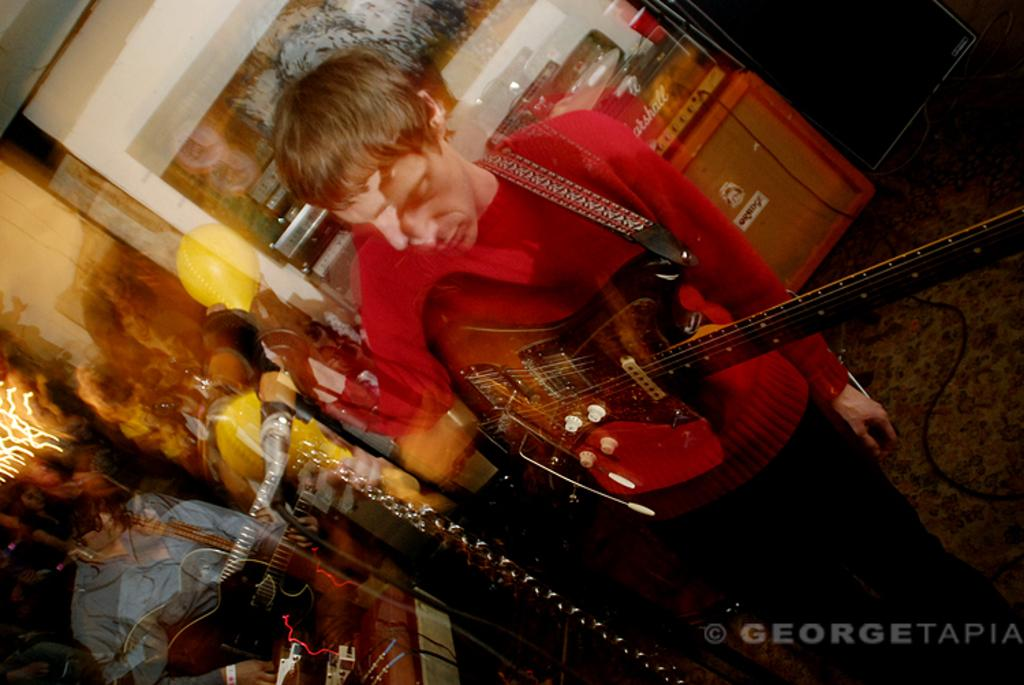What is the main subject of the image? The main subject of the image is a man. What is the man doing in the image? The man is standing in the image. What object is the man holding in the image? The man is holding a guitar in his hand. Can you see any mountains in the background of the image? There is no mention of mountains in the provided facts, so we cannot determine if any mountains are present. 